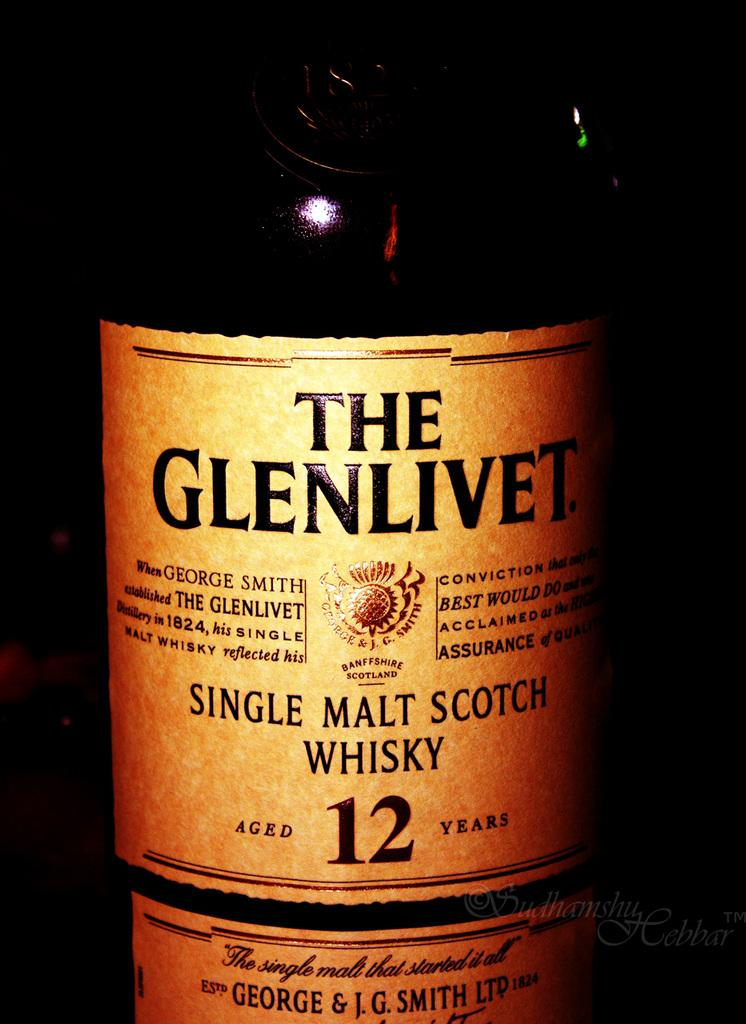<image>
Write a terse but informative summary of the picture. 12 Year old bottle of Glenlivet scotch whiskey. 